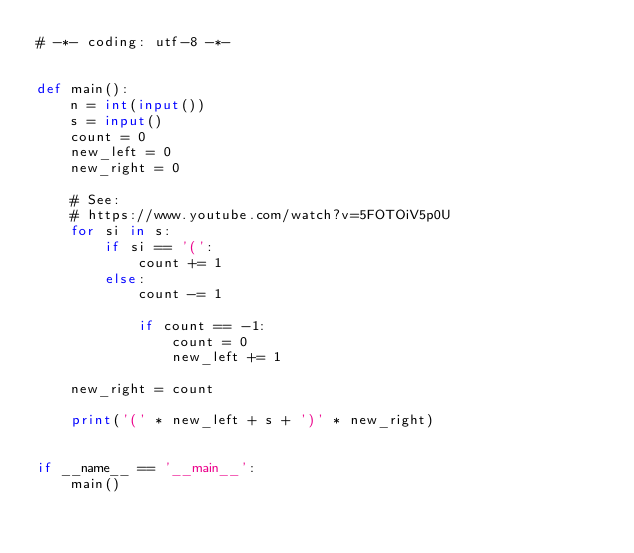Convert code to text. <code><loc_0><loc_0><loc_500><loc_500><_Python_># -*- coding: utf-8 -*-


def main():
    n = int(input())
    s = input()
    count = 0
    new_left = 0
    new_right = 0

    # See:
    # https://www.youtube.com/watch?v=5FOTOiV5p0U
    for si in s:
        if si == '(':
            count += 1
        else:
            count -= 1

            if count == -1:
                count = 0
                new_left += 1

    new_right = count

    print('(' * new_left + s + ')' * new_right)


if __name__ == '__main__':
    main()</code> 